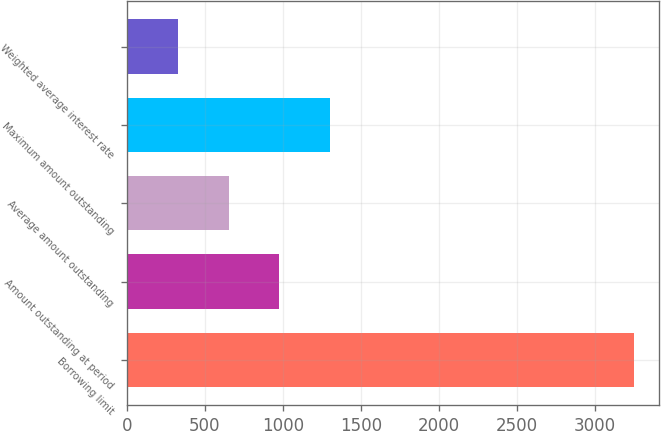Convert chart to OTSL. <chart><loc_0><loc_0><loc_500><loc_500><bar_chart><fcel>Borrowing limit<fcel>Amount outstanding at period<fcel>Average amount outstanding<fcel>Maximum amount outstanding<fcel>Weighted average interest rate<nl><fcel>3250<fcel>975.96<fcel>651.09<fcel>1300.83<fcel>326.22<nl></chart> 